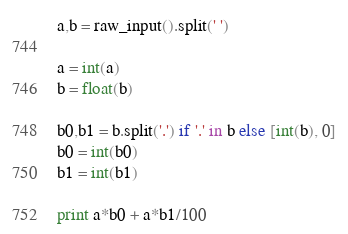Convert code to text. <code><loc_0><loc_0><loc_500><loc_500><_Python_>a,b = raw_input().split(' ')

a = int(a)
b = float(b)

b0,b1 = b.split('.') if '.' in b else [int(b), 0]
b0 = int(b0)
b1 = int(b1)

print a*b0 + a*b1/100 
</code> 